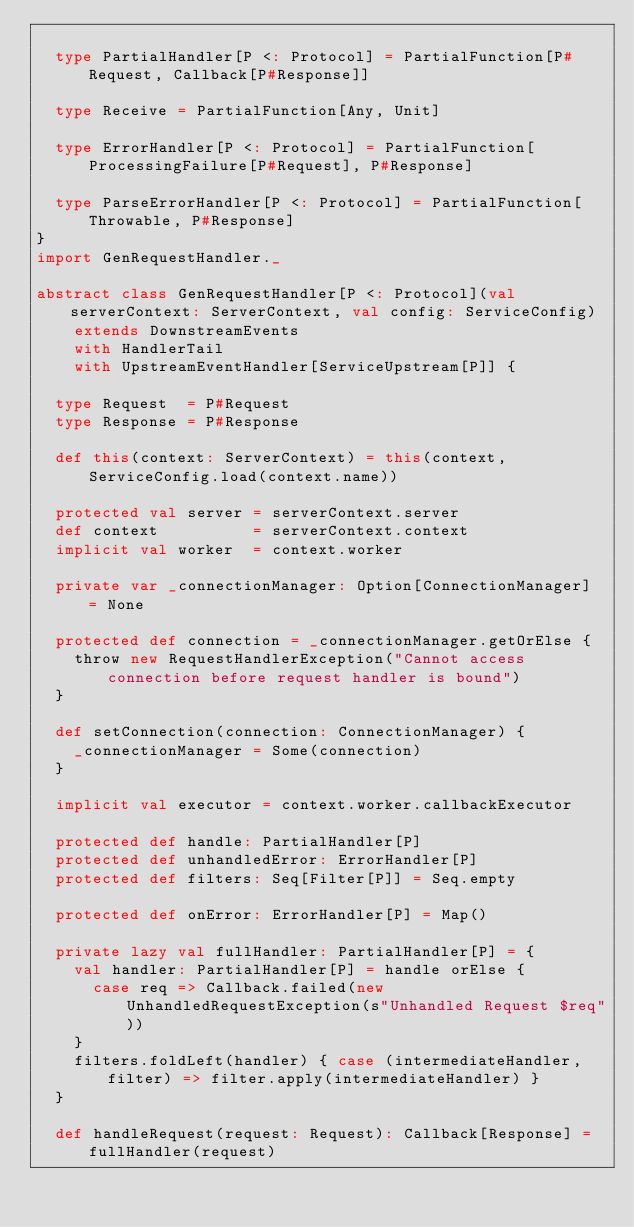<code> <loc_0><loc_0><loc_500><loc_500><_Scala_>
  type PartialHandler[P <: Protocol] = PartialFunction[P#Request, Callback[P#Response]]

  type Receive = PartialFunction[Any, Unit]

  type ErrorHandler[P <: Protocol] = PartialFunction[ProcessingFailure[P#Request], P#Response]

  type ParseErrorHandler[P <: Protocol] = PartialFunction[Throwable, P#Response]
}
import GenRequestHandler._

abstract class GenRequestHandler[P <: Protocol](val serverContext: ServerContext, val config: ServiceConfig)
    extends DownstreamEvents
    with HandlerTail
    with UpstreamEventHandler[ServiceUpstream[P]] {

  type Request  = P#Request
  type Response = P#Response

  def this(context: ServerContext) = this(context, ServiceConfig.load(context.name))

  protected val server = serverContext.server
  def context          = serverContext.context
  implicit val worker  = context.worker

  private var _connectionManager: Option[ConnectionManager] = None

  protected def connection = _connectionManager.getOrElse {
    throw new RequestHandlerException("Cannot access connection before request handler is bound")
  }

  def setConnection(connection: ConnectionManager) {
    _connectionManager = Some(connection)
  }

  implicit val executor = context.worker.callbackExecutor

  protected def handle: PartialHandler[P]
  protected def unhandledError: ErrorHandler[P]
  protected def filters: Seq[Filter[P]] = Seq.empty

  protected def onError: ErrorHandler[P] = Map()

  private lazy val fullHandler: PartialHandler[P] = {
    val handler: PartialHandler[P] = handle orElse {
      case req => Callback.failed(new UnhandledRequestException(s"Unhandled Request $req"))
    }
    filters.foldLeft(handler) { case (intermediateHandler, filter) => filter.apply(intermediateHandler) }
  }

  def handleRequest(request: Request): Callback[Response] = fullHandler(request)
</code> 